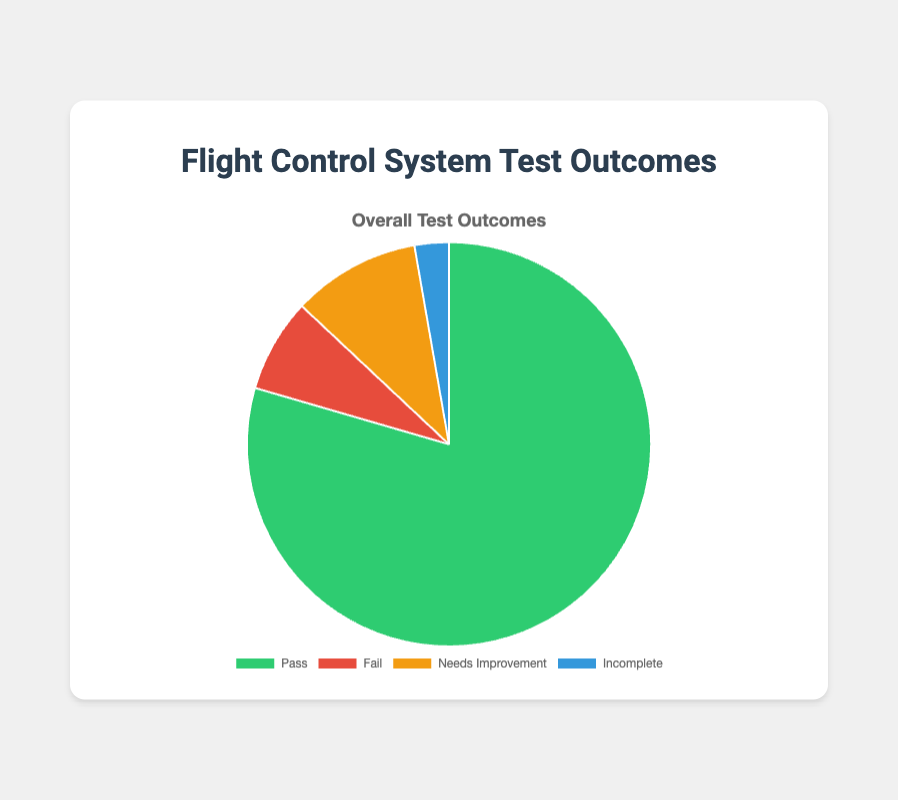What percentage of the test outcomes were a 'Fail'? The pie chart is composed of four segments representing 'Pass', 'Fail', 'Needs Improvement', and 'Incomplete'. To find the percentage that 'Fail' represents, locate the 'Fail' segment and read the percentage value.
Answer: 6.35% Which test outcome had the highest percentage? By looking at the pie chart, observe which segment is the largest in size. This largest segment corresponds to the 'Pass' category.
Answer: Pass What is the sum of 'Needs Improvement' and 'Fail' test outcomes? From the dataset, add the values of 'Needs Improvement' (41) and 'Fail' (30). The sum is 41 + 30 = 71.
Answer: 71 Which color represents 'Incomplete' in the pie chart? The 'Incomplete' category is the smallest segment in the chart. Identify its corresponding color, which is blue.
Answer: Blue Is the number of 'Pass' outcomes more than the combined count of 'Fail' and 'Needs Improvement'? Compare 318 (Pass) with the sum of 'Fail' (30) and 'Needs Improvement' (41). Since 318 > (30 + 41), the 'Pass' outcomes are more.
Answer: Yes By how much do the 'Pass' test outcomes exceed the 'Fail' test outcomes? Subtract the 'Fail' outcomes (30) from the 'Pass' outcomes (318): 318 - 30 = 288.
Answer: 288 Are the 'Incomplete' outcomes greater than 2% of the total outcomes? First, calculate the total outcomes: 318 + 30 + 41 + 11 = 400. Then, find 2% of 400: (2/100) * 400 = 8. Check if the 'Incomplete' outcomes (11) are greater than 8.
Answer: Yes Which segment appears the smallest in size compared to others? Observe the pie chart and identify the smallest segment. It is the 'Incomplete' segment.
Answer: Incomplete What proportion of test outcomes are other than 'Pass'? To find the proportion of outcomes different from 'Pass', sum the counts of 'Fail' (30), 'Needs Improvement' (41), and 'Incomplete' (11), and divide by the total outcomes (400): (30 + 41 + 11)/400.
Answer: 20.5% What visual attribute most clearly differentiates the 'Pass' segment from others? Examine the chart to see the distinct visual features of the 'Pass' segment compared to others, such as its size and color (green). The size is the most distinct feature indicating a high percentage.
Answer: Size 